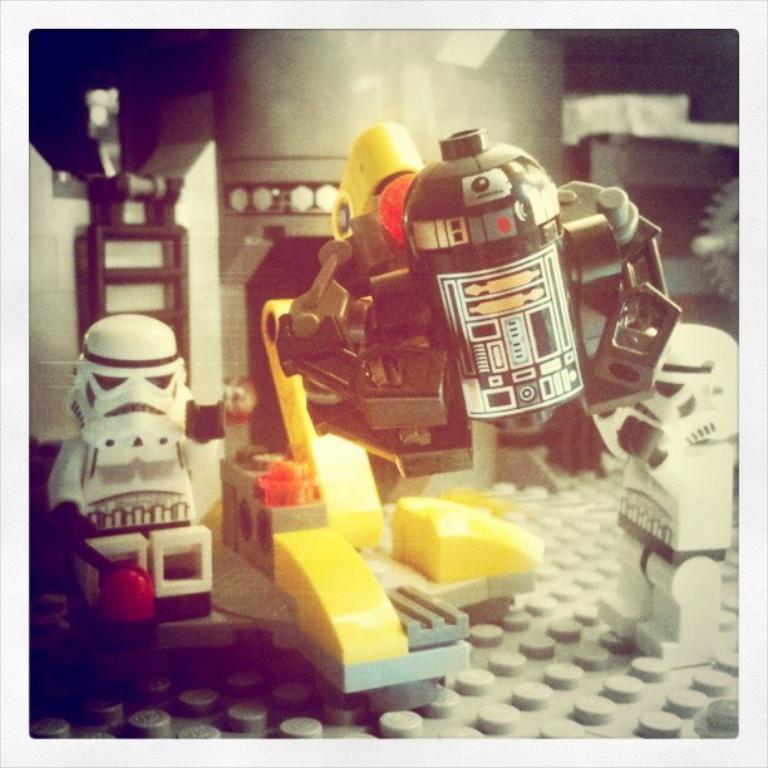Can you describe this image briefly? This image consists of a miniature. In which there are toys in different colors. They look like minions. 